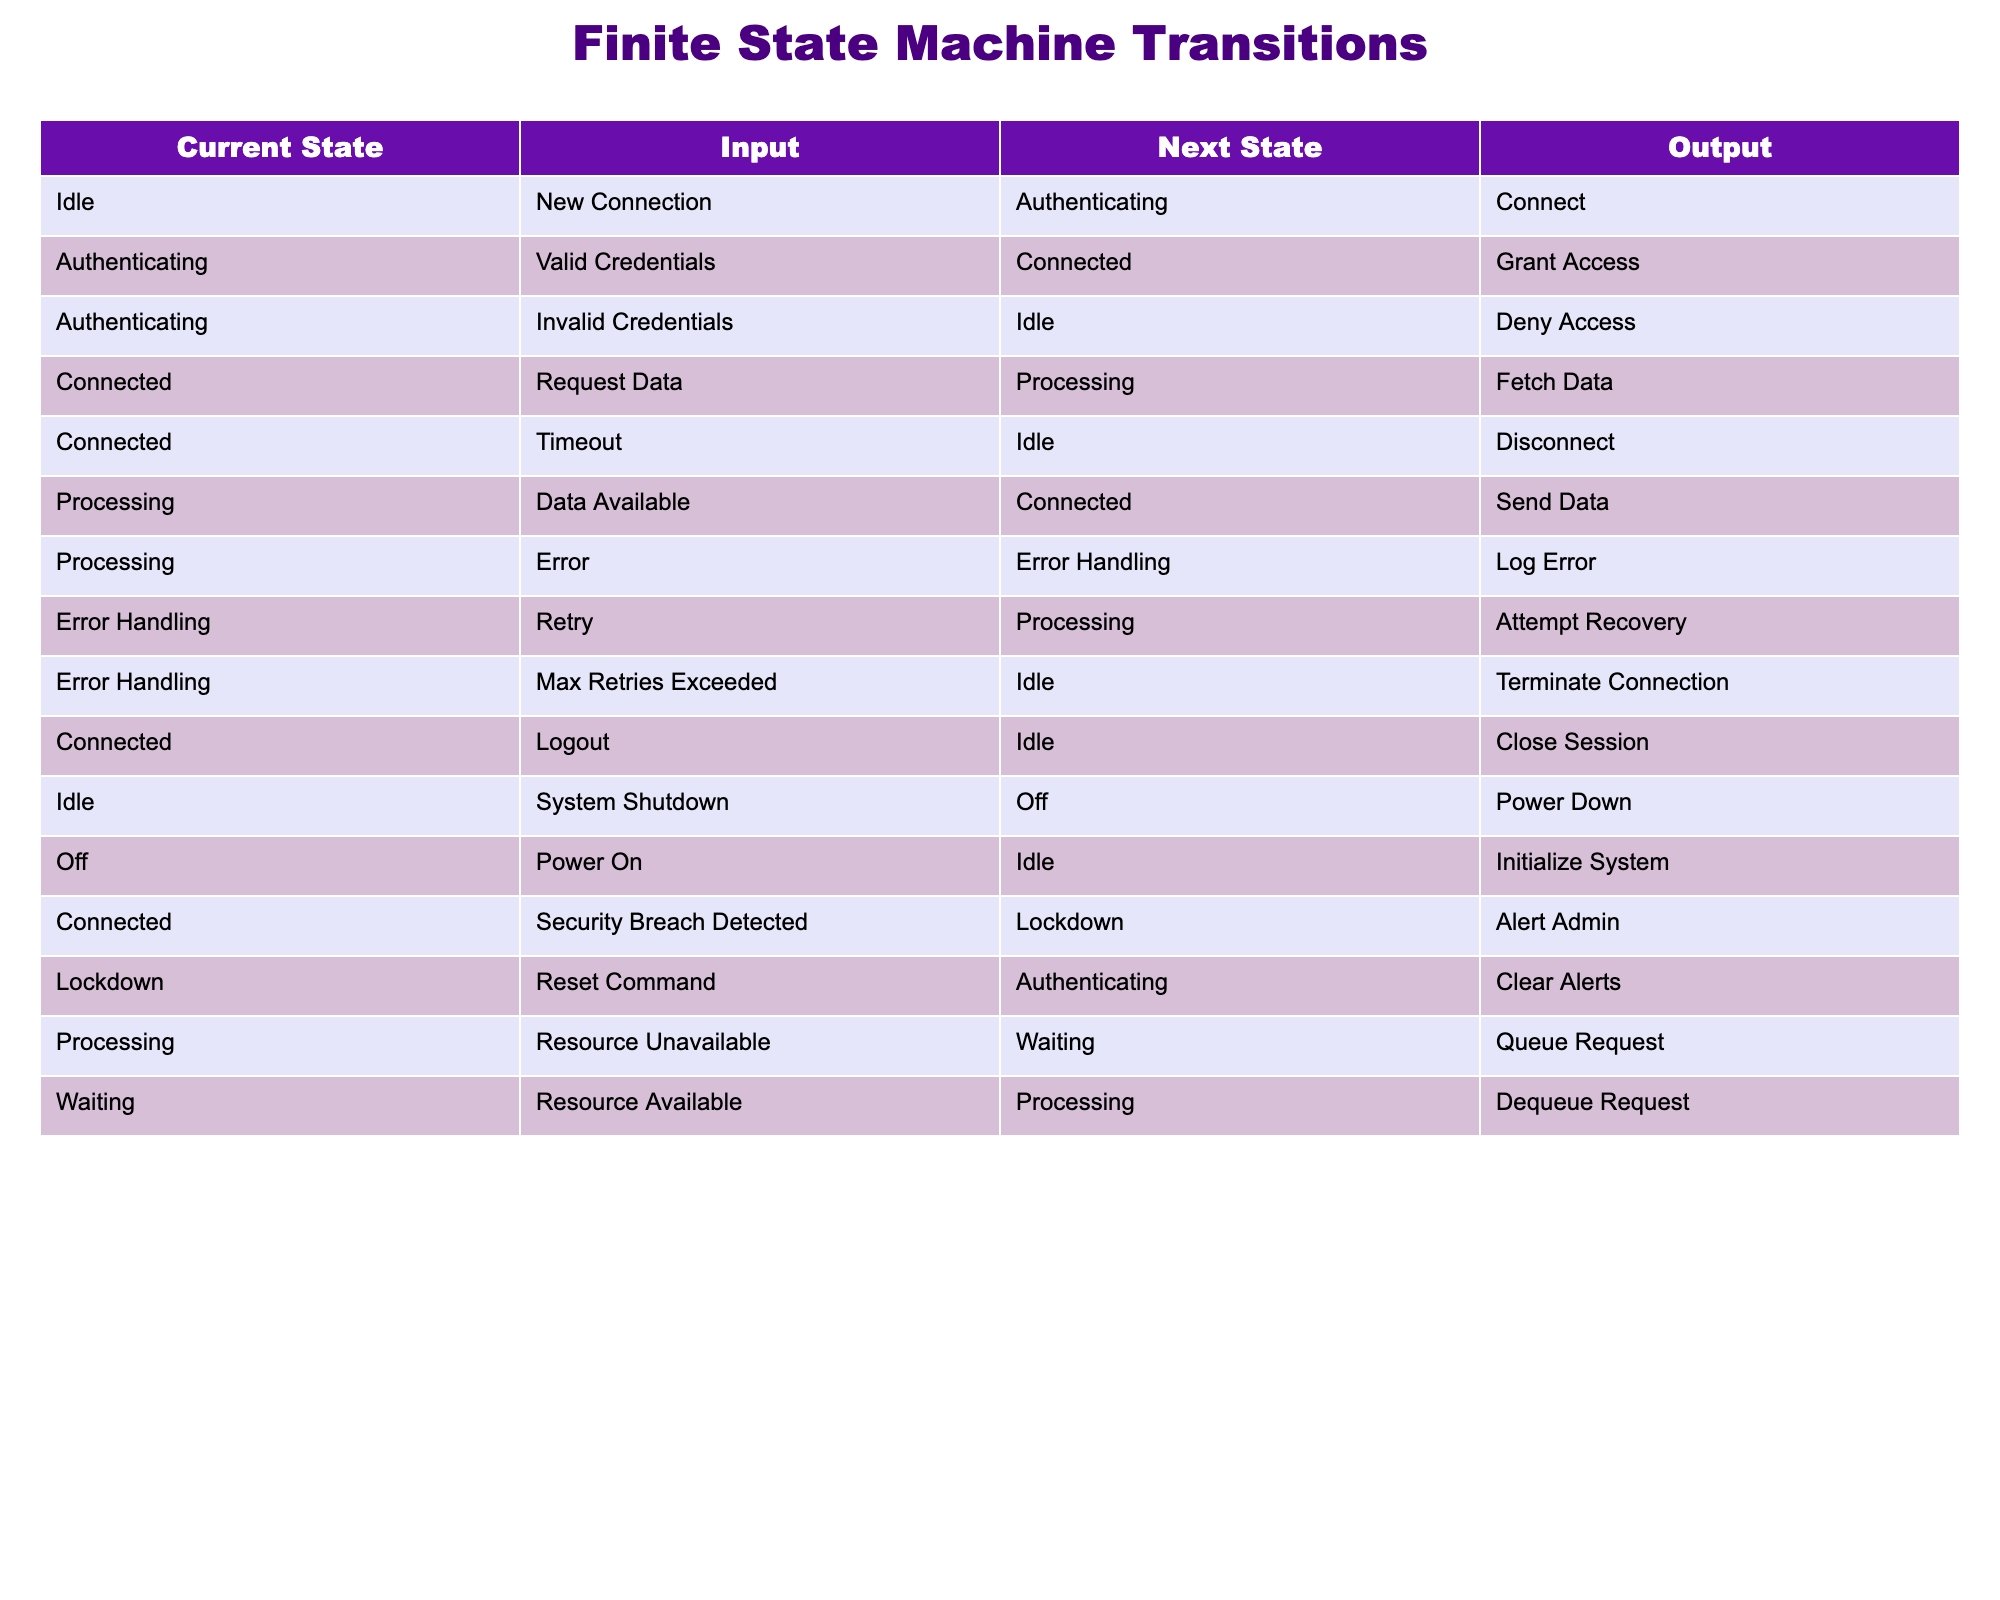What is the next state when the current state is "Idle" and the input is "New Connection"? According to the table, if the current state is "Idle" and the input is "New Connection," the next state is "Authenticating."
Answer: Authenticating What is the output when the current state is "Processing" and the input is "Data Available"? From the table, when in the "Processing" state with the "Data Available" input, the output is "Send Data."
Answer: Send Data Is it true that the state "Error Handling" can transition to the state "Processing"? The table shows that "Error Handling" can transition to "Processing" when the input is "Retry," making this statement true.
Answer: Yes How many distinct inputs can lead to the state "Connected"? The table lists two distinct inputs that can lead to the "Connected" state: "Valid Credentials" and "Logout." Thus, there are a total of two distinct inputs.
Answer: 2 What are the current states that can lead to the output "Disconnect"? Upon checking the table, the current state "Connected" with the input "Timeout" leads to the output "Disconnect." Therefore, the only current state that results in this output is "Connected."
Answer: Connected What is the sequence of events starting from "Idle" with input "New Connection" until reaching "Connected"? Starting from "Idle" with "New Connection," the state transitions to "Authenticating," where valid credentials lead to "Connected." Thus, Idle → Authenticating → Connected is the sequence for a successful connection.
Answer: Idle → Authenticating → Connected Can the state "Waiting" go to "Processing"? The table shows that the state "Waiting" transitions to "Processing" only when "Resource Available" is the input, confirming that this transition is possible under this condition.
Answer: Yes Which state directly precedes "Lockdown" when the current state is "Connected"? According to the transitions, "Lockdown" follows from "Connected" upon a "Security Breach Detected," making "Connected" the state that directly precedes "Lockdown."
Answer: Connected 